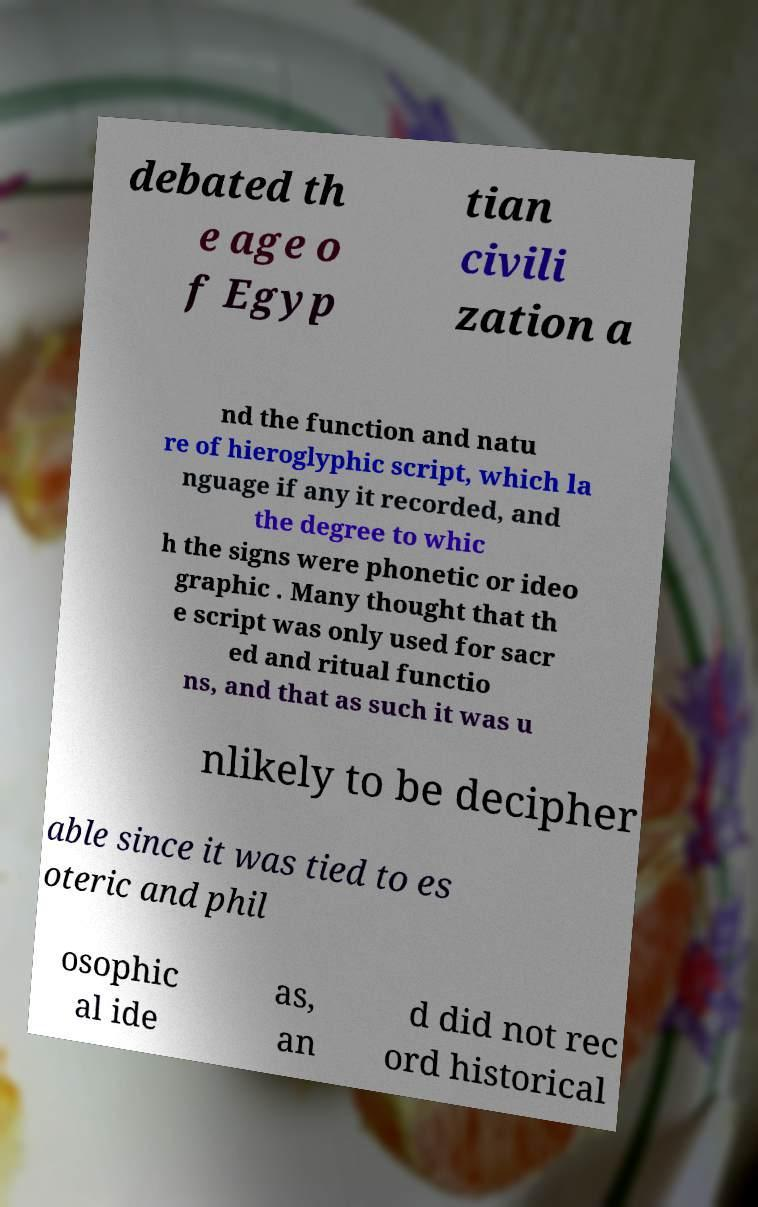For documentation purposes, I need the text within this image transcribed. Could you provide that? debated th e age o f Egyp tian civili zation a nd the function and natu re of hieroglyphic script, which la nguage if any it recorded, and the degree to whic h the signs were phonetic or ideo graphic . Many thought that th e script was only used for sacr ed and ritual functio ns, and that as such it was u nlikely to be decipher able since it was tied to es oteric and phil osophic al ide as, an d did not rec ord historical 